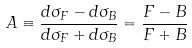Convert formula to latex. <formula><loc_0><loc_0><loc_500><loc_500>A \equiv \frac { d \sigma _ { F } - d \sigma _ { B } } { d \sigma _ { F } + d \sigma _ { B } } = \frac { F - B } { F + B }</formula> 